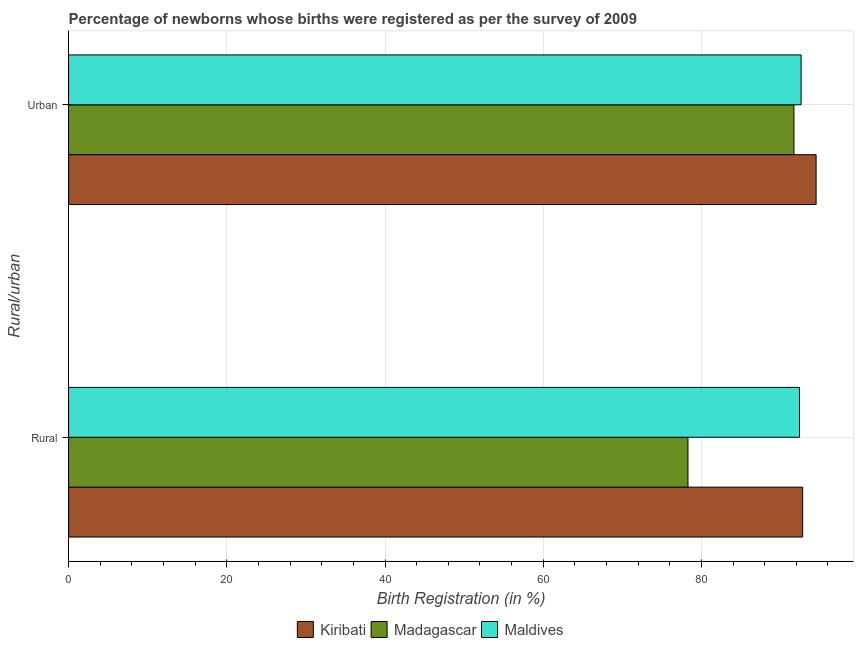Are the number of bars per tick equal to the number of legend labels?
Offer a terse response. Yes. Are the number of bars on each tick of the Y-axis equal?
Your answer should be very brief. Yes. What is the label of the 1st group of bars from the top?
Your response must be concise. Urban. What is the rural birth registration in Madagascar?
Offer a terse response. 78.3. Across all countries, what is the maximum urban birth registration?
Keep it short and to the point. 94.5. Across all countries, what is the minimum urban birth registration?
Provide a short and direct response. 91.7. In which country was the urban birth registration maximum?
Provide a short and direct response. Kiribati. In which country was the rural birth registration minimum?
Provide a succinct answer. Madagascar. What is the total urban birth registration in the graph?
Your answer should be compact. 278.8. What is the difference between the rural birth registration in Kiribati and the urban birth registration in Maldives?
Provide a succinct answer. 0.2. What is the average urban birth registration per country?
Provide a succinct answer. 92.93. What is the difference between the urban birth registration and rural birth registration in Maldives?
Provide a short and direct response. 0.2. In how many countries, is the urban birth registration greater than 4 %?
Provide a succinct answer. 3. What is the ratio of the urban birth registration in Madagascar to that in Maldives?
Ensure brevity in your answer.  0.99. Is the urban birth registration in Madagascar less than that in Maldives?
Your answer should be very brief. Yes. What does the 3rd bar from the top in Rural represents?
Give a very brief answer. Kiribati. What does the 2nd bar from the bottom in Urban represents?
Provide a short and direct response. Madagascar. How many bars are there?
Your answer should be very brief. 6. Are all the bars in the graph horizontal?
Offer a terse response. Yes. How many countries are there in the graph?
Your answer should be very brief. 3. What is the difference between two consecutive major ticks on the X-axis?
Make the answer very short. 20. Where does the legend appear in the graph?
Your response must be concise. Bottom center. What is the title of the graph?
Offer a very short reply. Percentage of newborns whose births were registered as per the survey of 2009. What is the label or title of the X-axis?
Make the answer very short. Birth Registration (in %). What is the label or title of the Y-axis?
Offer a terse response. Rural/urban. What is the Birth Registration (in %) in Kiribati in Rural?
Your answer should be very brief. 92.8. What is the Birth Registration (in %) of Madagascar in Rural?
Your response must be concise. 78.3. What is the Birth Registration (in %) in Maldives in Rural?
Ensure brevity in your answer.  92.4. What is the Birth Registration (in %) in Kiribati in Urban?
Provide a succinct answer. 94.5. What is the Birth Registration (in %) of Madagascar in Urban?
Offer a very short reply. 91.7. What is the Birth Registration (in %) of Maldives in Urban?
Provide a short and direct response. 92.6. Across all Rural/urban, what is the maximum Birth Registration (in %) of Kiribati?
Make the answer very short. 94.5. Across all Rural/urban, what is the maximum Birth Registration (in %) in Madagascar?
Provide a succinct answer. 91.7. Across all Rural/urban, what is the maximum Birth Registration (in %) of Maldives?
Make the answer very short. 92.6. Across all Rural/urban, what is the minimum Birth Registration (in %) of Kiribati?
Your answer should be very brief. 92.8. Across all Rural/urban, what is the minimum Birth Registration (in %) in Madagascar?
Ensure brevity in your answer.  78.3. Across all Rural/urban, what is the minimum Birth Registration (in %) of Maldives?
Your response must be concise. 92.4. What is the total Birth Registration (in %) in Kiribati in the graph?
Give a very brief answer. 187.3. What is the total Birth Registration (in %) in Madagascar in the graph?
Provide a short and direct response. 170. What is the total Birth Registration (in %) of Maldives in the graph?
Offer a terse response. 185. What is the difference between the Birth Registration (in %) in Madagascar in Rural and that in Urban?
Offer a very short reply. -13.4. What is the difference between the Birth Registration (in %) of Kiribati in Rural and the Birth Registration (in %) of Maldives in Urban?
Your answer should be very brief. 0.2. What is the difference between the Birth Registration (in %) of Madagascar in Rural and the Birth Registration (in %) of Maldives in Urban?
Ensure brevity in your answer.  -14.3. What is the average Birth Registration (in %) in Kiribati per Rural/urban?
Your answer should be compact. 93.65. What is the average Birth Registration (in %) in Madagascar per Rural/urban?
Give a very brief answer. 85. What is the average Birth Registration (in %) in Maldives per Rural/urban?
Provide a succinct answer. 92.5. What is the difference between the Birth Registration (in %) in Madagascar and Birth Registration (in %) in Maldives in Rural?
Make the answer very short. -14.1. What is the difference between the Birth Registration (in %) in Kiribati and Birth Registration (in %) in Madagascar in Urban?
Make the answer very short. 2.8. What is the ratio of the Birth Registration (in %) in Madagascar in Rural to that in Urban?
Your response must be concise. 0.85. What is the difference between the highest and the second highest Birth Registration (in %) in Madagascar?
Give a very brief answer. 13.4. What is the difference between the highest and the lowest Birth Registration (in %) in Madagascar?
Your answer should be compact. 13.4. What is the difference between the highest and the lowest Birth Registration (in %) of Maldives?
Provide a short and direct response. 0.2. 